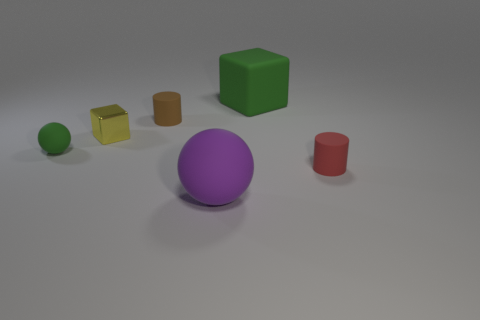There is a rubber sphere that is the same color as the big rubber cube; what size is it?
Your answer should be compact. Small. What size is the rubber thing that is both behind the small yellow cube and to the right of the purple ball?
Offer a very short reply. Large. The small thing that is right of the purple rubber thing has what shape?
Offer a terse response. Cylinder. Does the big green block have the same material as the sphere that is right of the brown matte thing?
Make the answer very short. Yes. Is the shape of the yellow metallic object the same as the large green thing?
Offer a very short reply. Yes. What material is the other thing that is the same shape as the red object?
Provide a succinct answer. Rubber. What color is the small thing that is both on the right side of the shiny thing and behind the small red matte cylinder?
Your response must be concise. Brown. The big matte block has what color?
Your response must be concise. Green. There is a small thing that is the same color as the rubber cube; what is it made of?
Offer a very short reply. Rubber. Is there a small yellow shiny thing that has the same shape as the big green matte object?
Provide a succinct answer. Yes. 